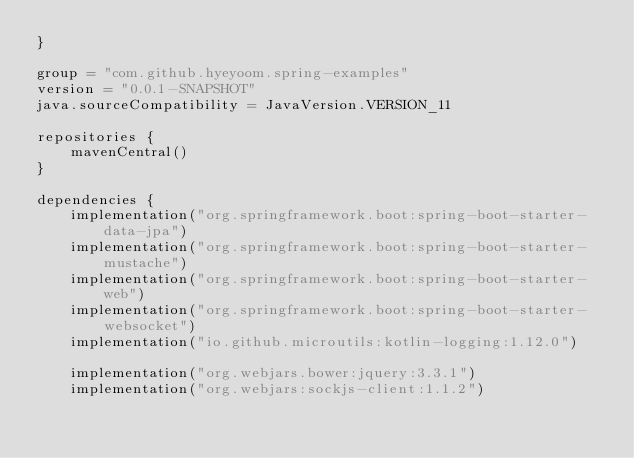Convert code to text. <code><loc_0><loc_0><loc_500><loc_500><_Kotlin_>}

group = "com.github.hyeyoom.spring-examples"
version = "0.0.1-SNAPSHOT"
java.sourceCompatibility = JavaVersion.VERSION_11

repositories {
    mavenCentral()
}

dependencies {
    implementation("org.springframework.boot:spring-boot-starter-data-jpa")
    implementation("org.springframework.boot:spring-boot-starter-mustache")
    implementation("org.springframework.boot:spring-boot-starter-web")
    implementation("org.springframework.boot:spring-boot-starter-websocket")
    implementation("io.github.microutils:kotlin-logging:1.12.0")

    implementation("org.webjars.bower:jquery:3.3.1")
    implementation("org.webjars:sockjs-client:1.1.2")</code> 